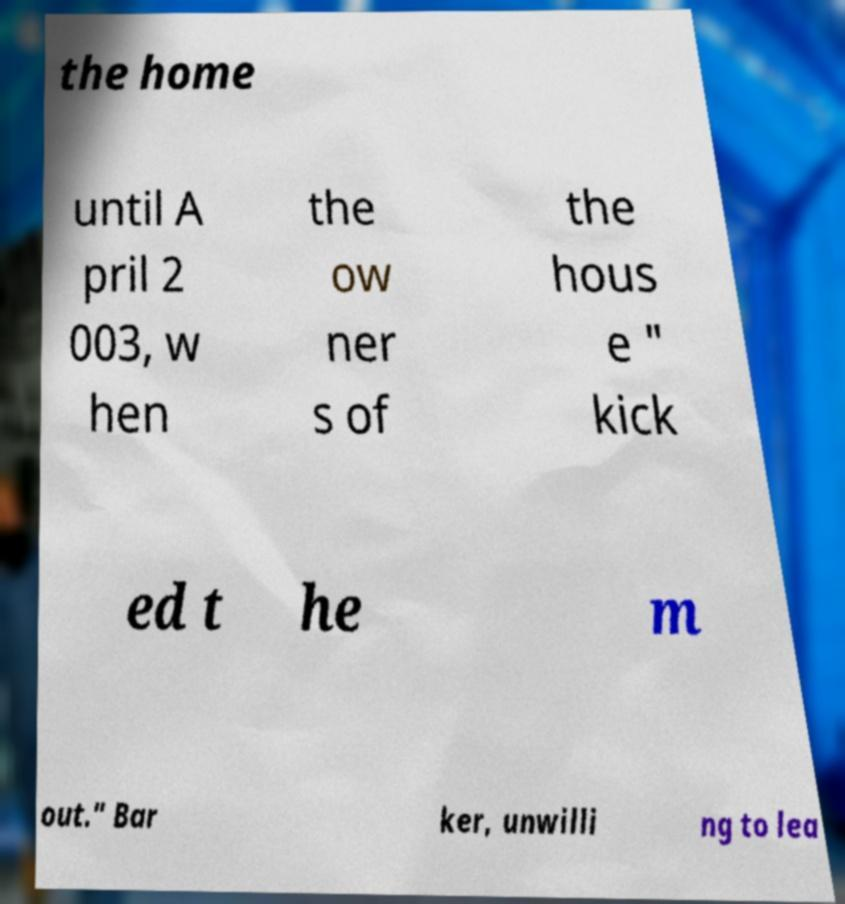Can you read and provide the text displayed in the image?This photo seems to have some interesting text. Can you extract and type it out for me? the home until A pril 2 003, w hen the ow ner s of the hous e " kick ed t he m out." Bar ker, unwilli ng to lea 